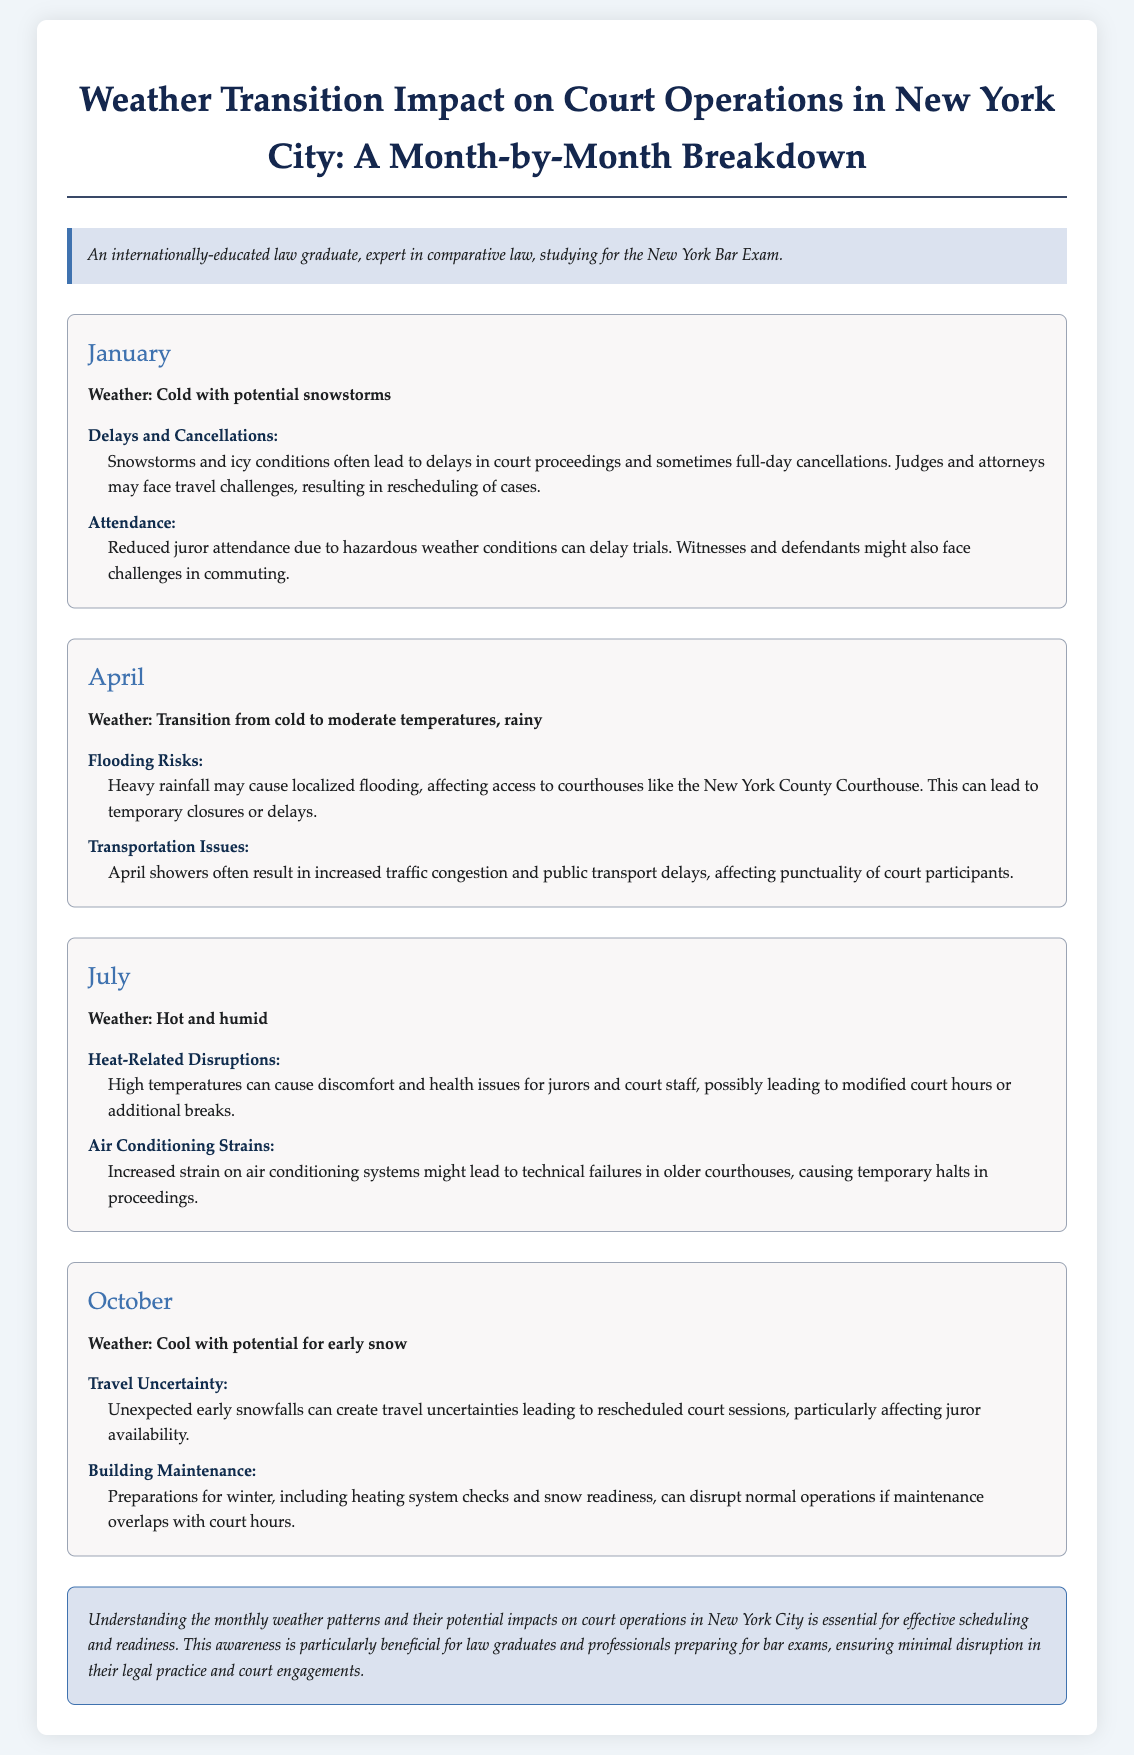What is the weather condition in January? The document states that January's weather is "Cold with potential snowstorms."
Answer: Cold with potential snowstorms What are the impacts on court attendance in January? The document lists reduced juror attendance due to hazardous weather conditions as impacts in January.
Answer: Reduced juror attendance What risks are highlighted for April? The document mentions "Flooding Risks" and "Transportation Issues" as impacts related to April's weather.
Answer: Flooding Risks What health-related issue is mentioned for July? The document indicates "Heat-Related Disruptions" due to high temperatures which can cause discomfort.
Answer: Heat-Related Disruptions What potential issue in October is associated with travel? The document highlights "Travel Uncertainty" due to unexpected early snowfalls affecting juror availability.
Answer: Travel Uncertainty What can lead to disruptions in court operations in July? According to the document, increased strain on air conditioning systems might lead to disruptions.
Answer: Air Conditioning Strains How may heavy rainfall in April affect courthouses specifically? The document states that heavy rainfall may cause localized flooding affecting access to courthouses.
Answer: Localized flooding What is a key conclusion regarding weather and court operations? The document emphasizes that understanding weather patterns is essential for effective scheduling of court operations.
Answer: Effective scheduling 